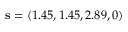<formula> <loc_0><loc_0><loc_500><loc_500>s = ( 1 . 4 5 , 1 . 4 5 , 2 . 8 9 , 0 )</formula> 